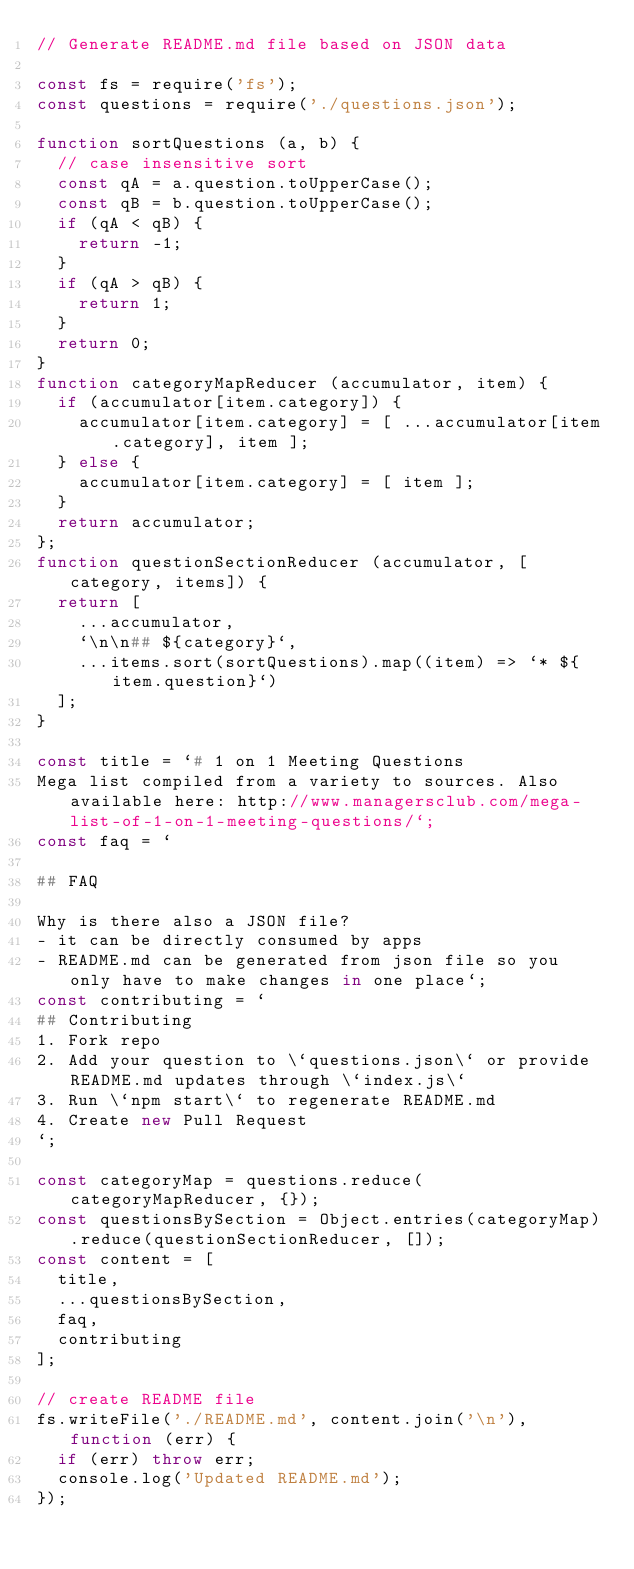<code> <loc_0><loc_0><loc_500><loc_500><_JavaScript_>// Generate README.md file based on JSON data

const fs = require('fs');
const questions = require('./questions.json');

function sortQuestions (a, b) {
  // case insensitive sort
  const qA = a.question.toUpperCase();
  const qB = b.question.toUpperCase();
  if (qA < qB) {
    return -1;
  }
  if (qA > qB) {
    return 1;
  }
  return 0;
}
function categoryMapReducer (accumulator, item) {
  if (accumulator[item.category]) {
    accumulator[item.category] = [ ...accumulator[item.category], item ];
  } else {
    accumulator[item.category] = [ item ];
  }
  return accumulator;
};
function questionSectionReducer (accumulator, [category, items]) {
  return [
    ...accumulator,
    `\n\n## ${category}`,
    ...items.sort(sortQuestions).map((item) => `* ${item.question}`)
  ];
}

const title = `# 1 on 1 Meeting Questions
Mega list compiled from a variety to sources. Also available here: http://www.managersclub.com/mega-list-of-1-on-1-meeting-questions/`;
const faq = `

## FAQ

Why is there also a JSON file?
- it can be directly consumed by apps
- README.md can be generated from json file so you only have to make changes in one place`;
const contributing = `
## Contributing
1. Fork repo
2. Add your question to \`questions.json\` or provide README.md updates through \`index.js\`
3. Run \`npm start\` to regenerate README.md
4. Create new Pull Request
`;

const categoryMap = questions.reduce(categoryMapReducer, {});
const questionsBySection = Object.entries(categoryMap).reduce(questionSectionReducer, []);
const content = [
  title,
  ...questionsBySection,
  faq,
  contributing
];

// create README file
fs.writeFile('./README.md', content.join('\n'), function (err) {
  if (err) throw err;
  console.log('Updated README.md');
});

</code> 